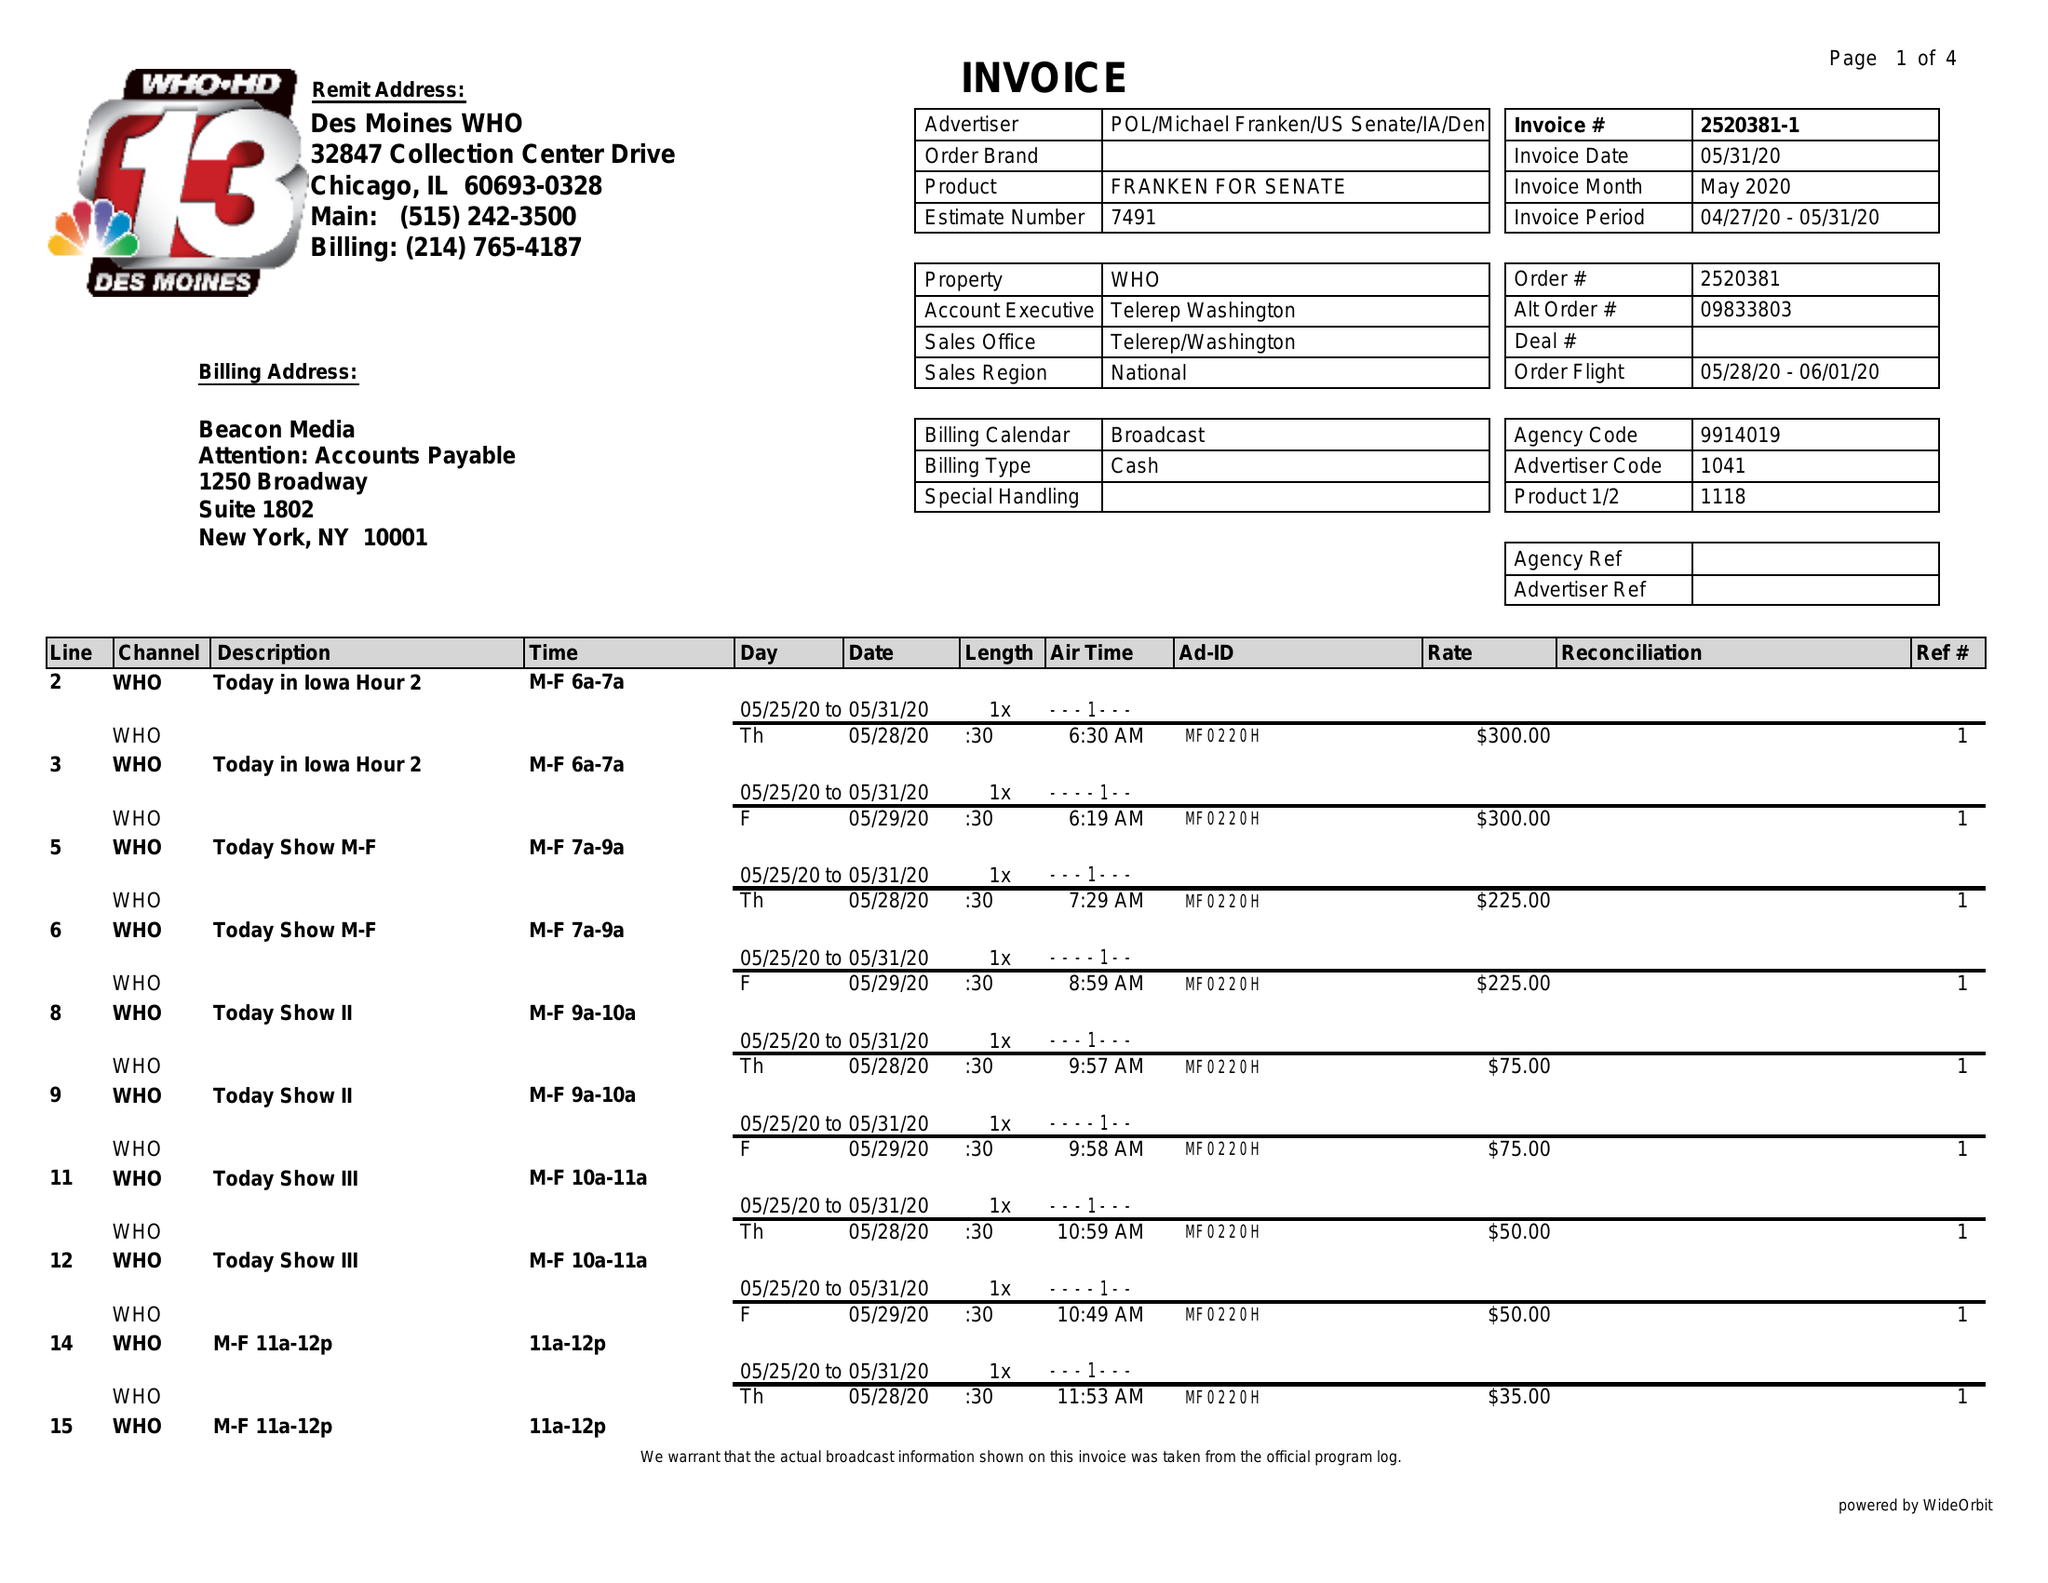What is the value for the contract_num?
Answer the question using a single word or phrase. 2520381 